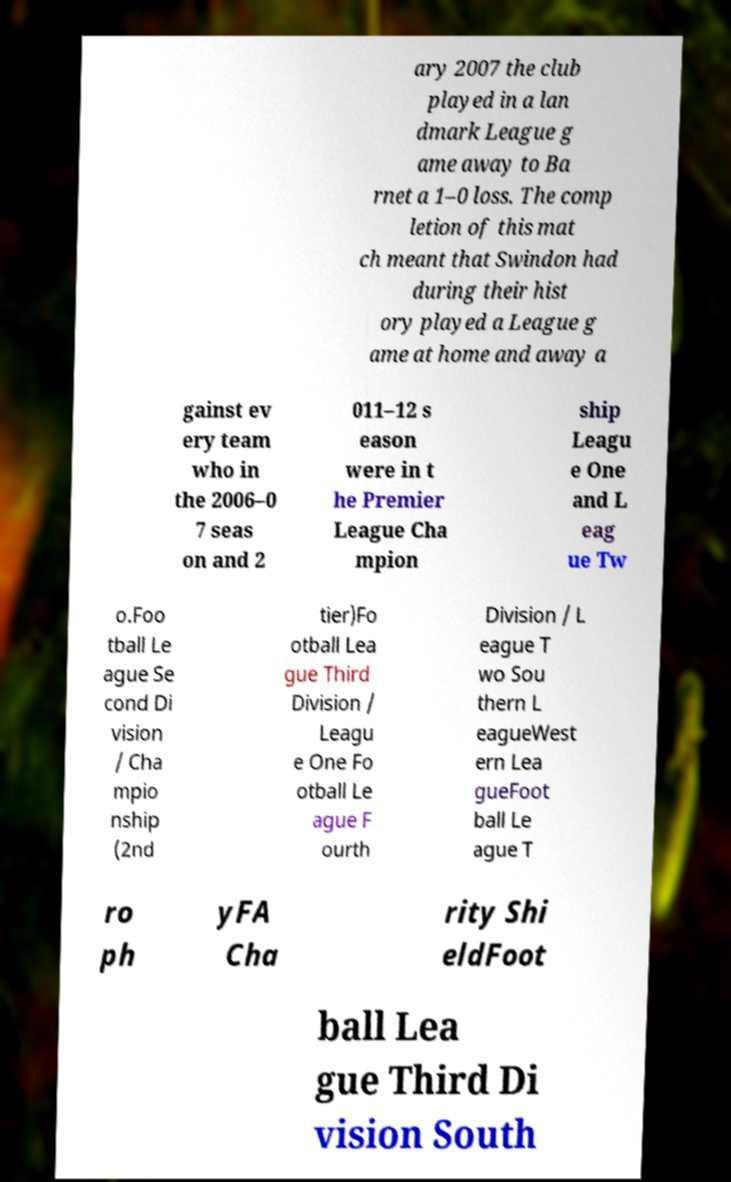What messages or text are displayed in this image? I need them in a readable, typed format. ary 2007 the club played in a lan dmark League g ame away to Ba rnet a 1–0 loss. The comp letion of this mat ch meant that Swindon had during their hist ory played a League g ame at home and away a gainst ev ery team who in the 2006–0 7 seas on and 2 011–12 s eason were in t he Premier League Cha mpion ship Leagu e One and L eag ue Tw o.Foo tball Le ague Se cond Di vision / Cha mpio nship (2nd tier)Fo otball Lea gue Third Division / Leagu e One Fo otball Le ague F ourth Division / L eague T wo Sou thern L eagueWest ern Lea gueFoot ball Le ague T ro ph yFA Cha rity Shi eldFoot ball Lea gue Third Di vision South 